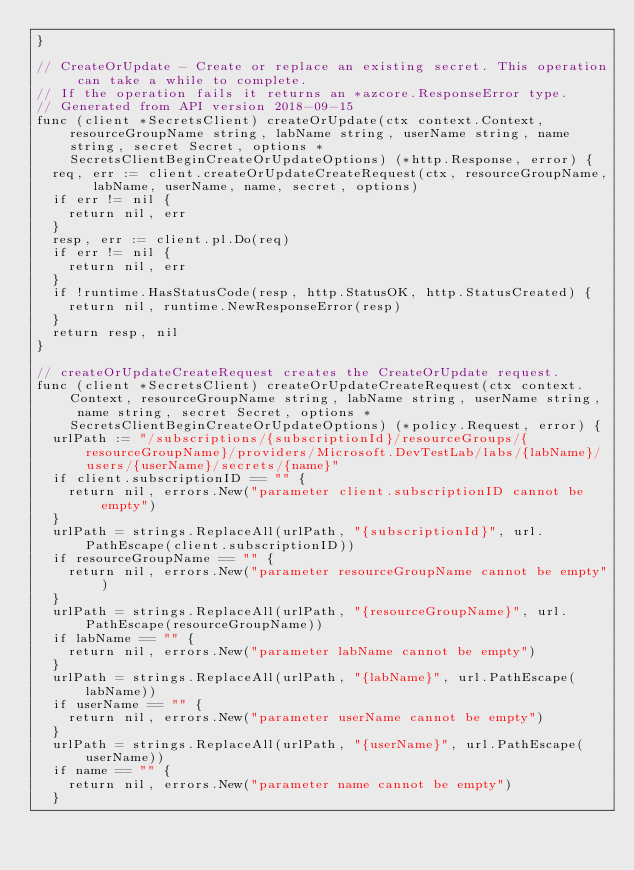Convert code to text. <code><loc_0><loc_0><loc_500><loc_500><_Go_>}

// CreateOrUpdate - Create or replace an existing secret. This operation can take a while to complete.
// If the operation fails it returns an *azcore.ResponseError type.
// Generated from API version 2018-09-15
func (client *SecretsClient) createOrUpdate(ctx context.Context, resourceGroupName string, labName string, userName string, name string, secret Secret, options *SecretsClientBeginCreateOrUpdateOptions) (*http.Response, error) {
	req, err := client.createOrUpdateCreateRequest(ctx, resourceGroupName, labName, userName, name, secret, options)
	if err != nil {
		return nil, err
	}
	resp, err := client.pl.Do(req)
	if err != nil {
		return nil, err
	}
	if !runtime.HasStatusCode(resp, http.StatusOK, http.StatusCreated) {
		return nil, runtime.NewResponseError(resp)
	}
	return resp, nil
}

// createOrUpdateCreateRequest creates the CreateOrUpdate request.
func (client *SecretsClient) createOrUpdateCreateRequest(ctx context.Context, resourceGroupName string, labName string, userName string, name string, secret Secret, options *SecretsClientBeginCreateOrUpdateOptions) (*policy.Request, error) {
	urlPath := "/subscriptions/{subscriptionId}/resourceGroups/{resourceGroupName}/providers/Microsoft.DevTestLab/labs/{labName}/users/{userName}/secrets/{name}"
	if client.subscriptionID == "" {
		return nil, errors.New("parameter client.subscriptionID cannot be empty")
	}
	urlPath = strings.ReplaceAll(urlPath, "{subscriptionId}", url.PathEscape(client.subscriptionID))
	if resourceGroupName == "" {
		return nil, errors.New("parameter resourceGroupName cannot be empty")
	}
	urlPath = strings.ReplaceAll(urlPath, "{resourceGroupName}", url.PathEscape(resourceGroupName))
	if labName == "" {
		return nil, errors.New("parameter labName cannot be empty")
	}
	urlPath = strings.ReplaceAll(urlPath, "{labName}", url.PathEscape(labName))
	if userName == "" {
		return nil, errors.New("parameter userName cannot be empty")
	}
	urlPath = strings.ReplaceAll(urlPath, "{userName}", url.PathEscape(userName))
	if name == "" {
		return nil, errors.New("parameter name cannot be empty")
	}</code> 